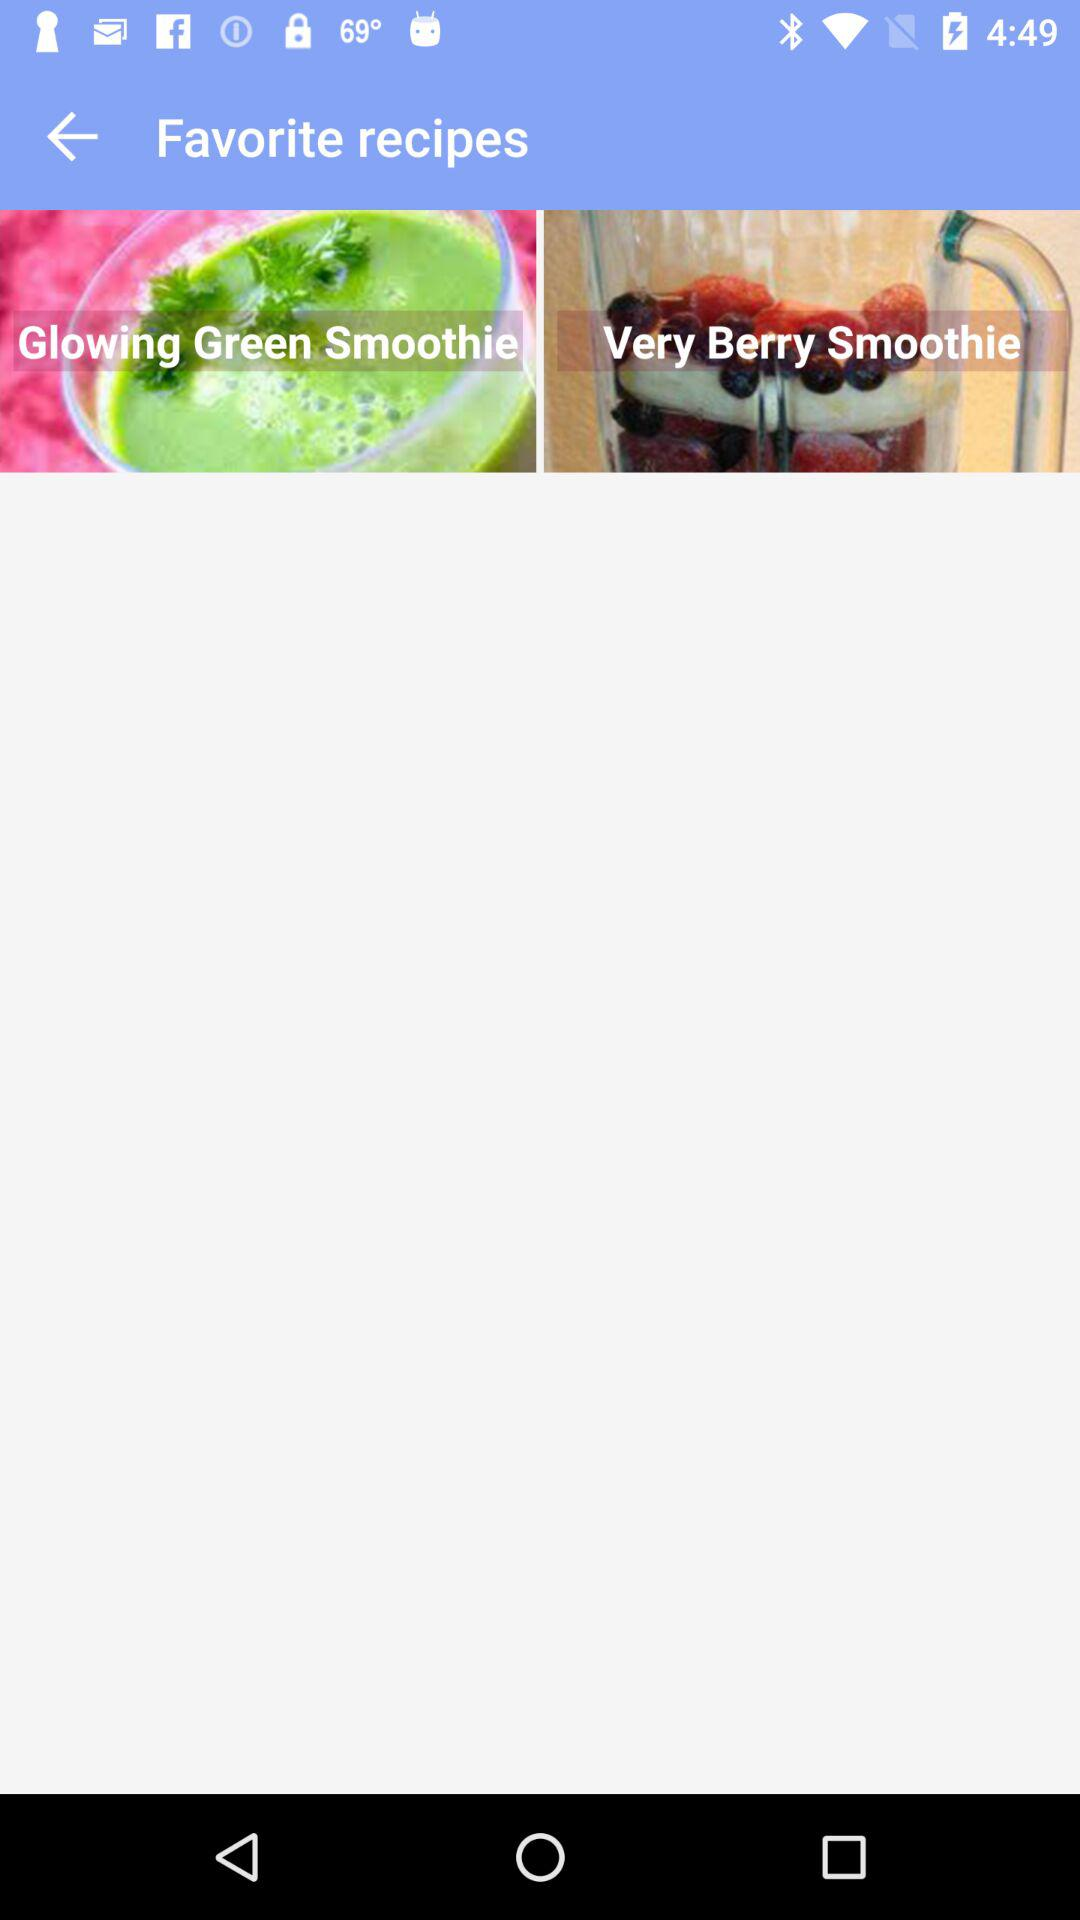What are the different types of smoothies shown on the screen? The different types of smoothies are "Glowing Green Smoothie" and "Very Berry Smoothie". 